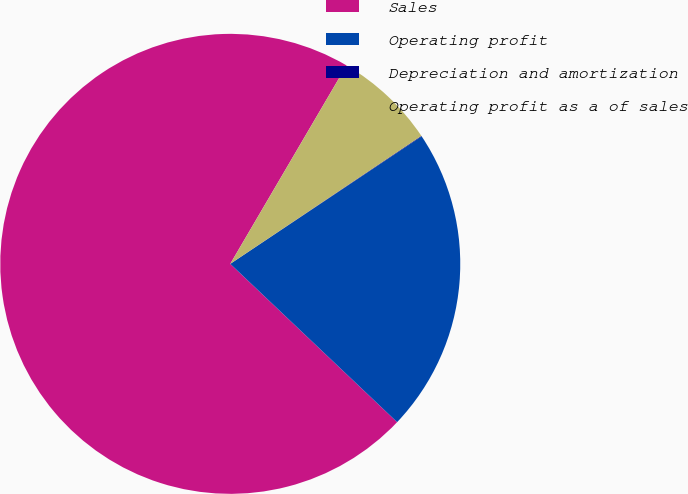<chart> <loc_0><loc_0><loc_500><loc_500><pie_chart><fcel>Sales<fcel>Operating profit<fcel>Depreciation and amortization<fcel>Operating profit as a of sales<nl><fcel>71.35%<fcel>21.43%<fcel>0.04%<fcel>7.17%<nl></chart> 